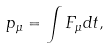<formula> <loc_0><loc_0><loc_500><loc_500>p _ { \mu } = \int F _ { \mu } d t ,</formula> 